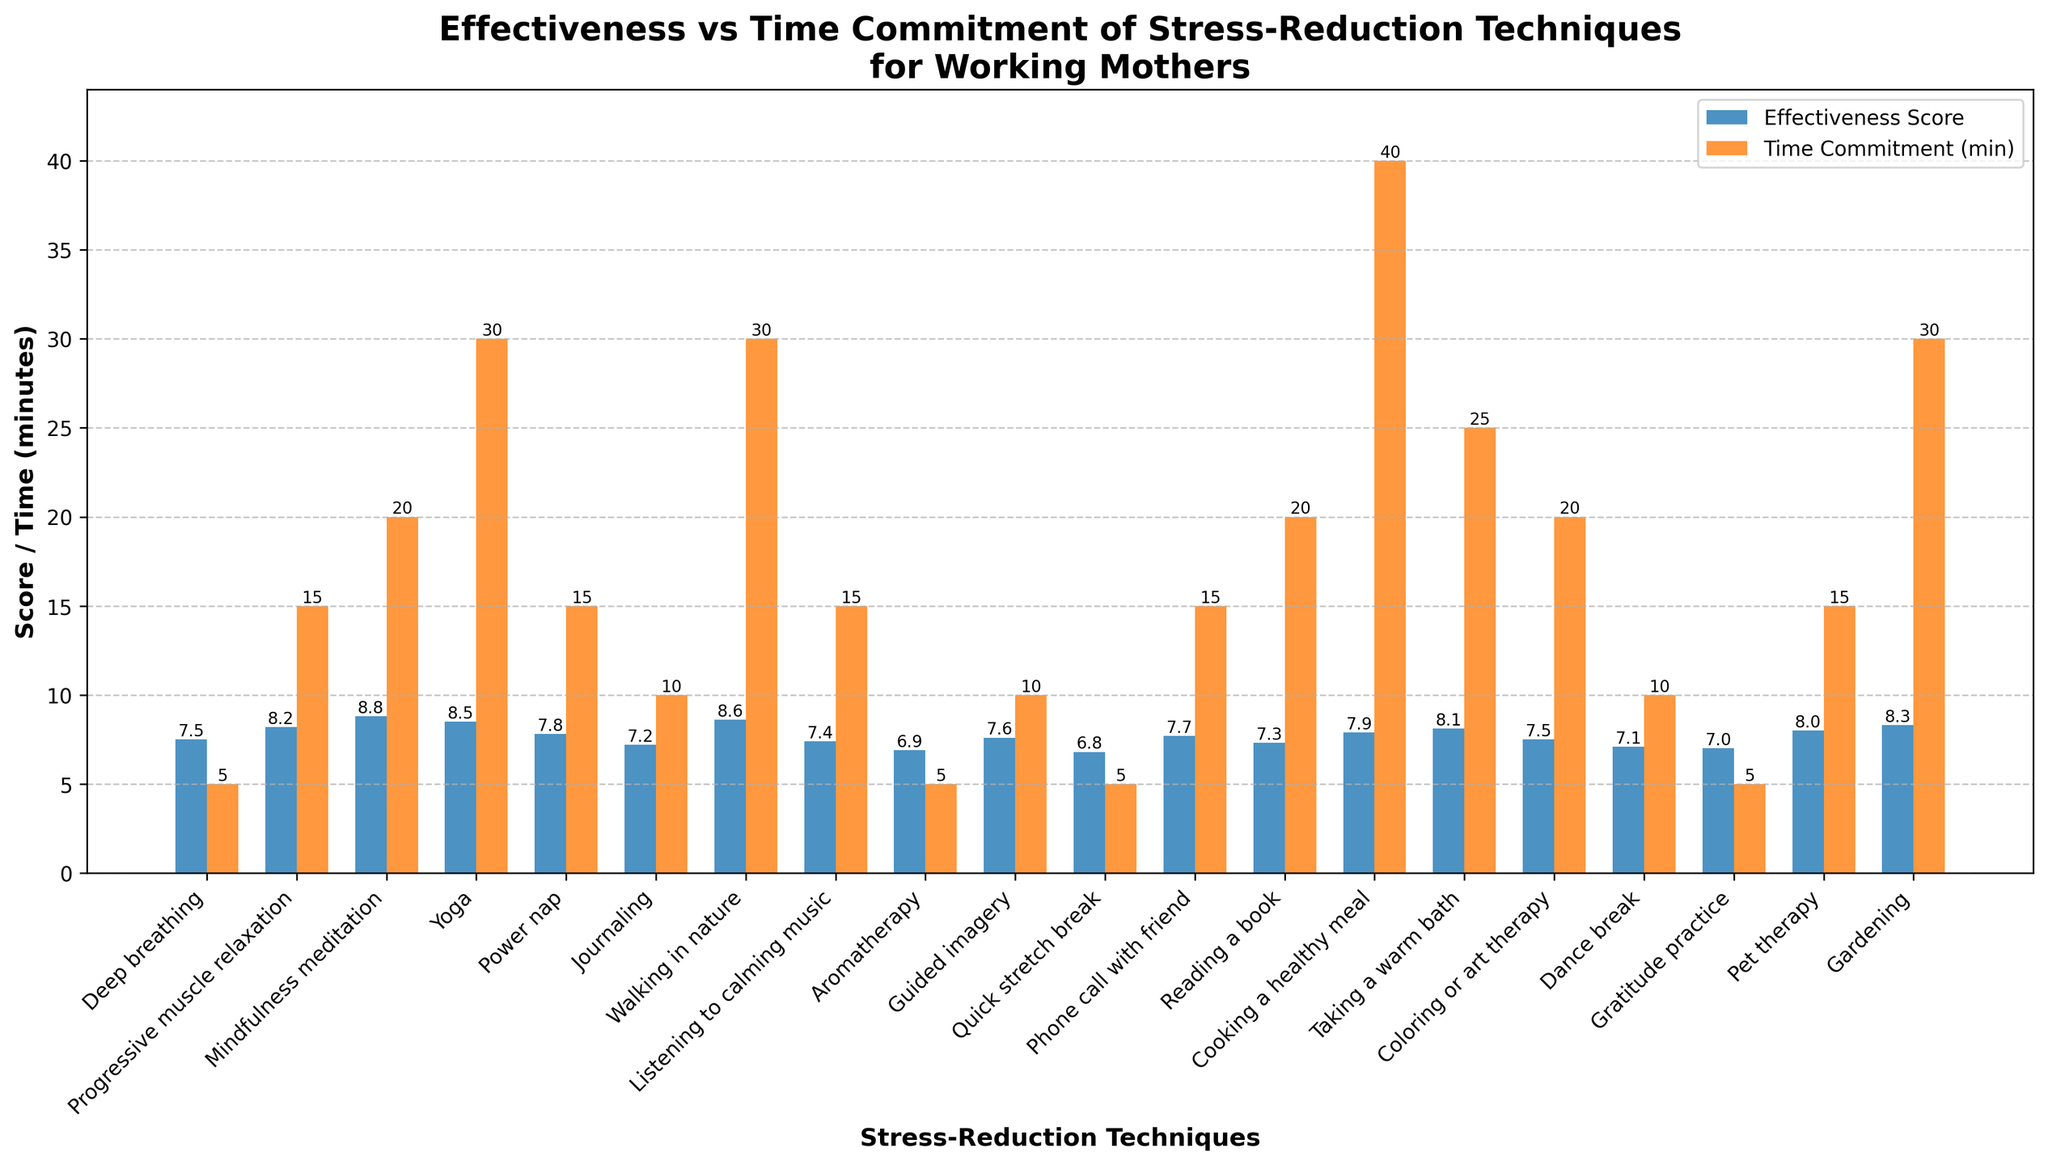What's the most effective stress-reduction technique? Identify the bar with the highest effectiveness score
Answer: Mindfulness meditation Which technique requires the least time commitment? Identify the bar representing the smallest number of minutes
Answer: Deep breathing, Aromatherapy, Quick stretch break, Gratitude practice (all require 5 minutes) What is the total time commitment for Progressive Muscle Relaxation and Walking in Nature? Add the time commitments of both techniques, 15 minutes + 30 minutes
Answer: 45 minutes Compare the effectiveness scores of Yoga and Gardening. Which is higher? Identify the effectiveness scores of both techniques and compare them (Yoga: 8.5, Gardening: 8.3)
Answer: Yoga What is the difference in time commitment between Cooking a Healthy Meal and Taking a Warm Bath? Subtract the time commitment of Taking a Warm Bath from that of Cooking a Healthy Meal (40 minutes - 25 minutes)
Answer: 15 minutes How many techniques have an effectiveness score of 8.0 or higher? Count all bars with effectiveness scores equal to or greater than 8.0
Answer: 7 techniques Which has a higher effectiveness score: Pet Therapy or Journaling? Identify the effectiveness scores of both techniques and compare them (Pet Therapy: 8.0, Journaling: 7.2)
Answer: Pet Therapy What is the average time commitment for techniques with effectiveness scores above 8.0? List out the time commitments of those techniques, sum them up, and then divide by the number of techniques (15+20+30+30+40+25+30 = 190; 190/7)
Answer: Approximately 27.1 minutes What is the difference in effectiveness scores between Progressive Muscle Relaxation and a Quick Stretch Break? Subtract the effectiveness score of Quick Stretch Break from that of Progressive Muscle Relaxation (8.2 - 6.8)
Answer: 1.4 Which technique has a similar time commitment to Listening to Calming Music but a higher effectiveness score? Identify techniques with a 15-minute time commitment and compare effectiveness scores. Pet Therapy (8.0) vs Listening to Calming Music (7.4)
Answer: Pet Therapy 